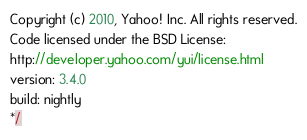Convert code to text. <code><loc_0><loc_0><loc_500><loc_500><_JavaScript_>Copyright (c) 2010, Yahoo! Inc. All rights reserved.
Code licensed under the BSD License:
http://developer.yahoo.com/yui/license.html
version: 3.4.0
build: nightly
*/</code> 